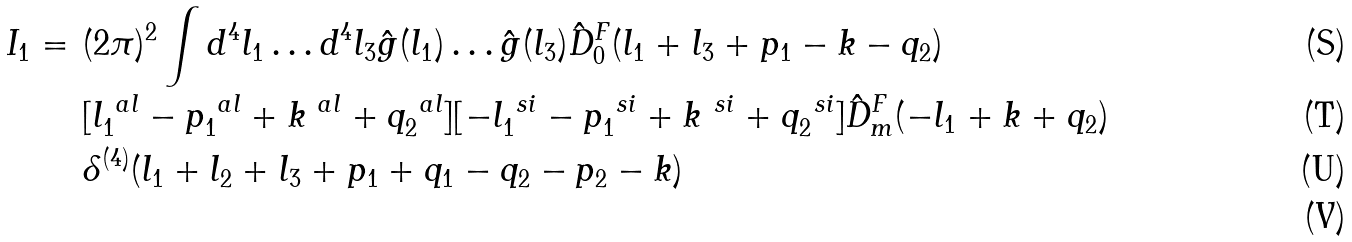Convert formula to latex. <formula><loc_0><loc_0><loc_500><loc_500>I _ { 1 } = & \ ( 2 \pi ) ^ { 2 } \int d ^ { 4 } l _ { 1 } \dots d ^ { 4 } l _ { 3 } \hat { g } ( l _ { 1 } ) \dots \hat { g } ( l _ { 3 } ) \hat { D } ^ { F } _ { 0 } ( l _ { 1 } + l _ { 3 } + p _ { 1 } - k - q _ { 2 } ) \\ & \ [ l _ { 1 } ^ { \ a l } - p _ { 1 } ^ { \ a l } + k ^ { \ a l } + q _ { 2 } ^ { \ a l } ] [ - l _ { 1 } ^ { \ s i } - p _ { 1 } ^ { \ s i } + k ^ { \ s i } + q _ { 2 } ^ { \ s i } ] \hat { D } ^ { F } _ { m } ( - l _ { 1 } + k + q _ { 2 } ) \\ & \ \delta ^ { ( 4 ) } ( l _ { 1 } + l _ { 2 } + l _ { 3 } + p _ { 1 } + q _ { 1 } - q _ { 2 } - p _ { 2 } - k ) \\</formula> 